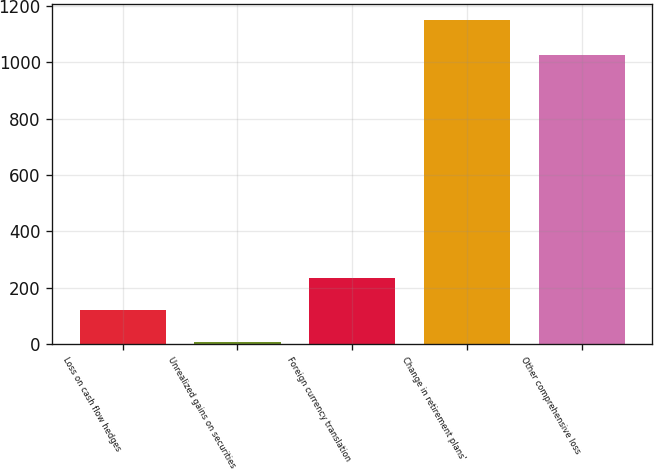Convert chart. <chart><loc_0><loc_0><loc_500><loc_500><bar_chart><fcel>Loss on cash flow hedges<fcel>Unrealized gains on securities<fcel>Foreign currency translation<fcel>Change in retirement plans'<fcel>Other comprehensive loss<nl><fcel>120.3<fcel>6<fcel>234.6<fcel>1149<fcel>1025<nl></chart> 